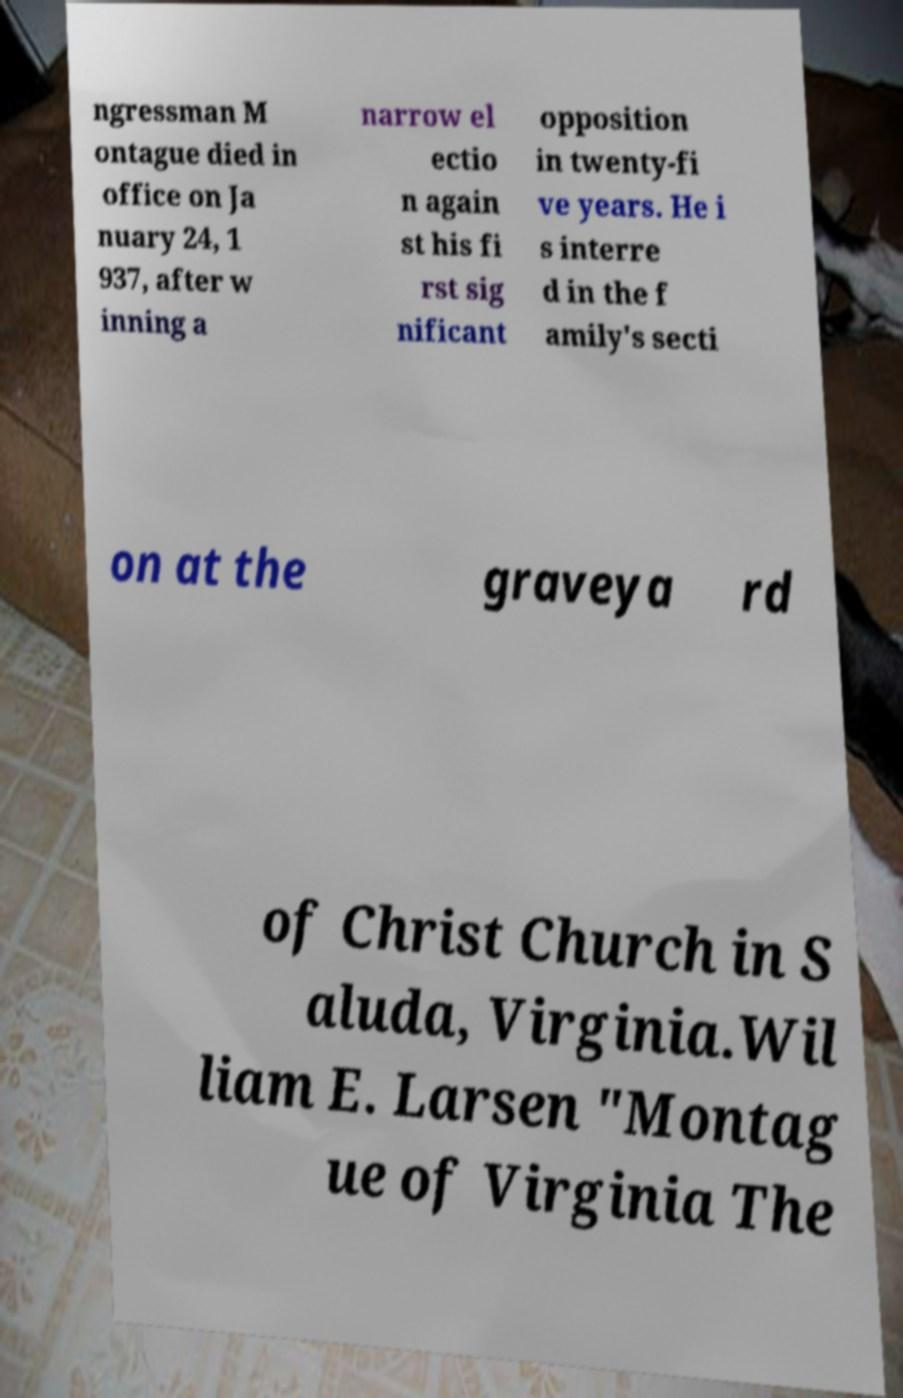Please read and relay the text visible in this image. What does it say? ngressman M ontague died in office on Ja nuary 24, 1 937, after w inning a narrow el ectio n again st his fi rst sig nificant opposition in twenty-fi ve years. He i s interre d in the f amily's secti on at the graveya rd of Christ Church in S aluda, Virginia.Wil liam E. Larsen "Montag ue of Virginia The 